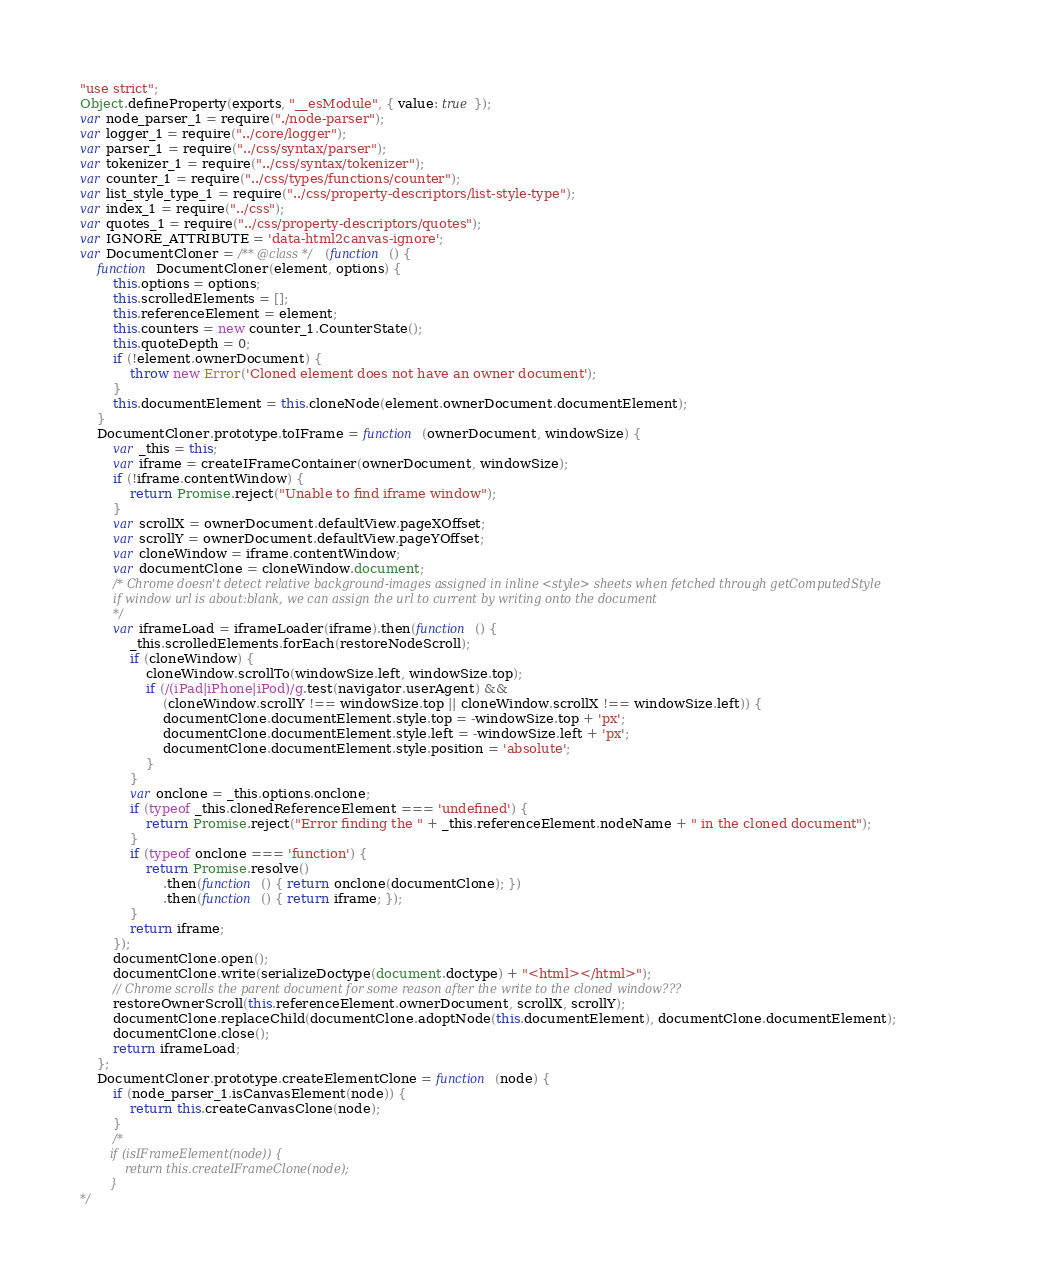Convert code to text. <code><loc_0><loc_0><loc_500><loc_500><_JavaScript_>"use strict";
Object.defineProperty(exports, "__esModule", { value: true });
var node_parser_1 = require("./node-parser");
var logger_1 = require("../core/logger");
var parser_1 = require("../css/syntax/parser");
var tokenizer_1 = require("../css/syntax/tokenizer");
var counter_1 = require("../css/types/functions/counter");
var list_style_type_1 = require("../css/property-descriptors/list-style-type");
var index_1 = require("../css");
var quotes_1 = require("../css/property-descriptors/quotes");
var IGNORE_ATTRIBUTE = 'data-html2canvas-ignore';
var DocumentCloner = /** @class */ (function () {
    function DocumentCloner(element, options) {
        this.options = options;
        this.scrolledElements = [];
        this.referenceElement = element;
        this.counters = new counter_1.CounterState();
        this.quoteDepth = 0;
        if (!element.ownerDocument) {
            throw new Error('Cloned element does not have an owner document');
        }
        this.documentElement = this.cloneNode(element.ownerDocument.documentElement);
    }
    DocumentCloner.prototype.toIFrame = function (ownerDocument, windowSize) {
        var _this = this;
        var iframe = createIFrameContainer(ownerDocument, windowSize);
        if (!iframe.contentWindow) {
            return Promise.reject("Unable to find iframe window");
        }
        var scrollX = ownerDocument.defaultView.pageXOffset;
        var scrollY = ownerDocument.defaultView.pageYOffset;
        var cloneWindow = iframe.contentWindow;
        var documentClone = cloneWindow.document;
        /* Chrome doesn't detect relative background-images assigned in inline <style> sheets when fetched through getComputedStyle
         if window url is about:blank, we can assign the url to current by writing onto the document
         */
        var iframeLoad = iframeLoader(iframe).then(function () {
            _this.scrolledElements.forEach(restoreNodeScroll);
            if (cloneWindow) {
                cloneWindow.scrollTo(windowSize.left, windowSize.top);
                if (/(iPad|iPhone|iPod)/g.test(navigator.userAgent) &&
                    (cloneWindow.scrollY !== windowSize.top || cloneWindow.scrollX !== windowSize.left)) {
                    documentClone.documentElement.style.top = -windowSize.top + 'px';
                    documentClone.documentElement.style.left = -windowSize.left + 'px';
                    documentClone.documentElement.style.position = 'absolute';
                }
            }
            var onclone = _this.options.onclone;
            if (typeof _this.clonedReferenceElement === 'undefined') {
                return Promise.reject("Error finding the " + _this.referenceElement.nodeName + " in the cloned document");
            }
            if (typeof onclone === 'function') {
                return Promise.resolve()
                    .then(function () { return onclone(documentClone); })
                    .then(function () { return iframe; });
            }
            return iframe;
        });
        documentClone.open();
        documentClone.write(serializeDoctype(document.doctype) + "<html></html>");
        // Chrome scrolls the parent document for some reason after the write to the cloned window???
        restoreOwnerScroll(this.referenceElement.ownerDocument, scrollX, scrollY);
        documentClone.replaceChild(documentClone.adoptNode(this.documentElement), documentClone.documentElement);
        documentClone.close();
        return iframeLoad;
    };
    DocumentCloner.prototype.createElementClone = function (node) {
        if (node_parser_1.isCanvasElement(node)) {
            return this.createCanvasClone(node);
        }
        /*
        if (isIFrameElement(node)) {
            return this.createIFrameClone(node);
        }
*/</code> 